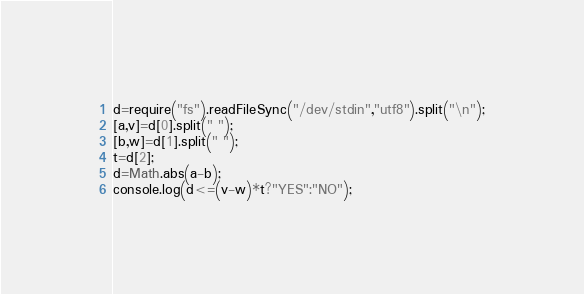Convert code to text. <code><loc_0><loc_0><loc_500><loc_500><_JavaScript_>d=require("fs").readFileSync("/dev/stdin","utf8").split("\n");
[a,v]=d[0].split(" ");
[b,w]=d[1].split(" ");
t=d[2];
d=Math.abs(a-b);
console.log(d<=(v-w)*t?"YES":"NO");</code> 